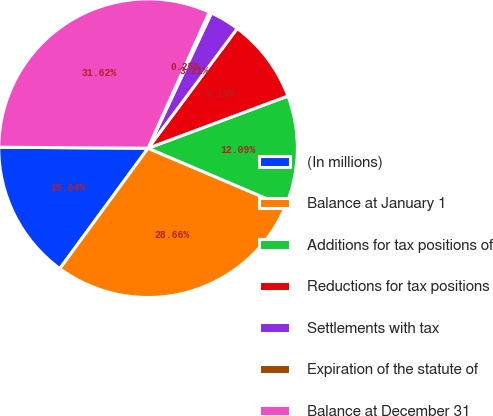Convert chart. <chart><loc_0><loc_0><loc_500><loc_500><pie_chart><fcel>(In millions)<fcel>Balance at January 1<fcel>Additions for tax positions of<fcel>Reductions for tax positions<fcel>Settlements with tax<fcel>Expiration of the statute of<fcel>Balance at December 31<nl><fcel>15.04%<fcel>28.66%<fcel>12.09%<fcel>9.13%<fcel>3.21%<fcel>0.25%<fcel>31.62%<nl></chart> 